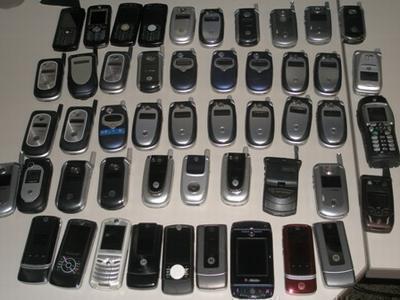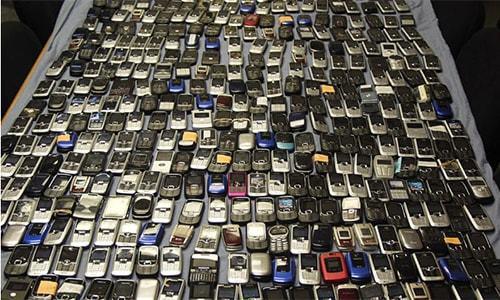The first image is the image on the left, the second image is the image on the right. For the images displayed, is the sentence "In both images there are many mobile phones from a variety of brands and models." factually correct? Answer yes or no. Yes. The first image is the image on the left, the second image is the image on the right. Analyze the images presented: Is the assertion "A large assortment of cell phones are seen in both images." valid? Answer yes or no. Yes. 